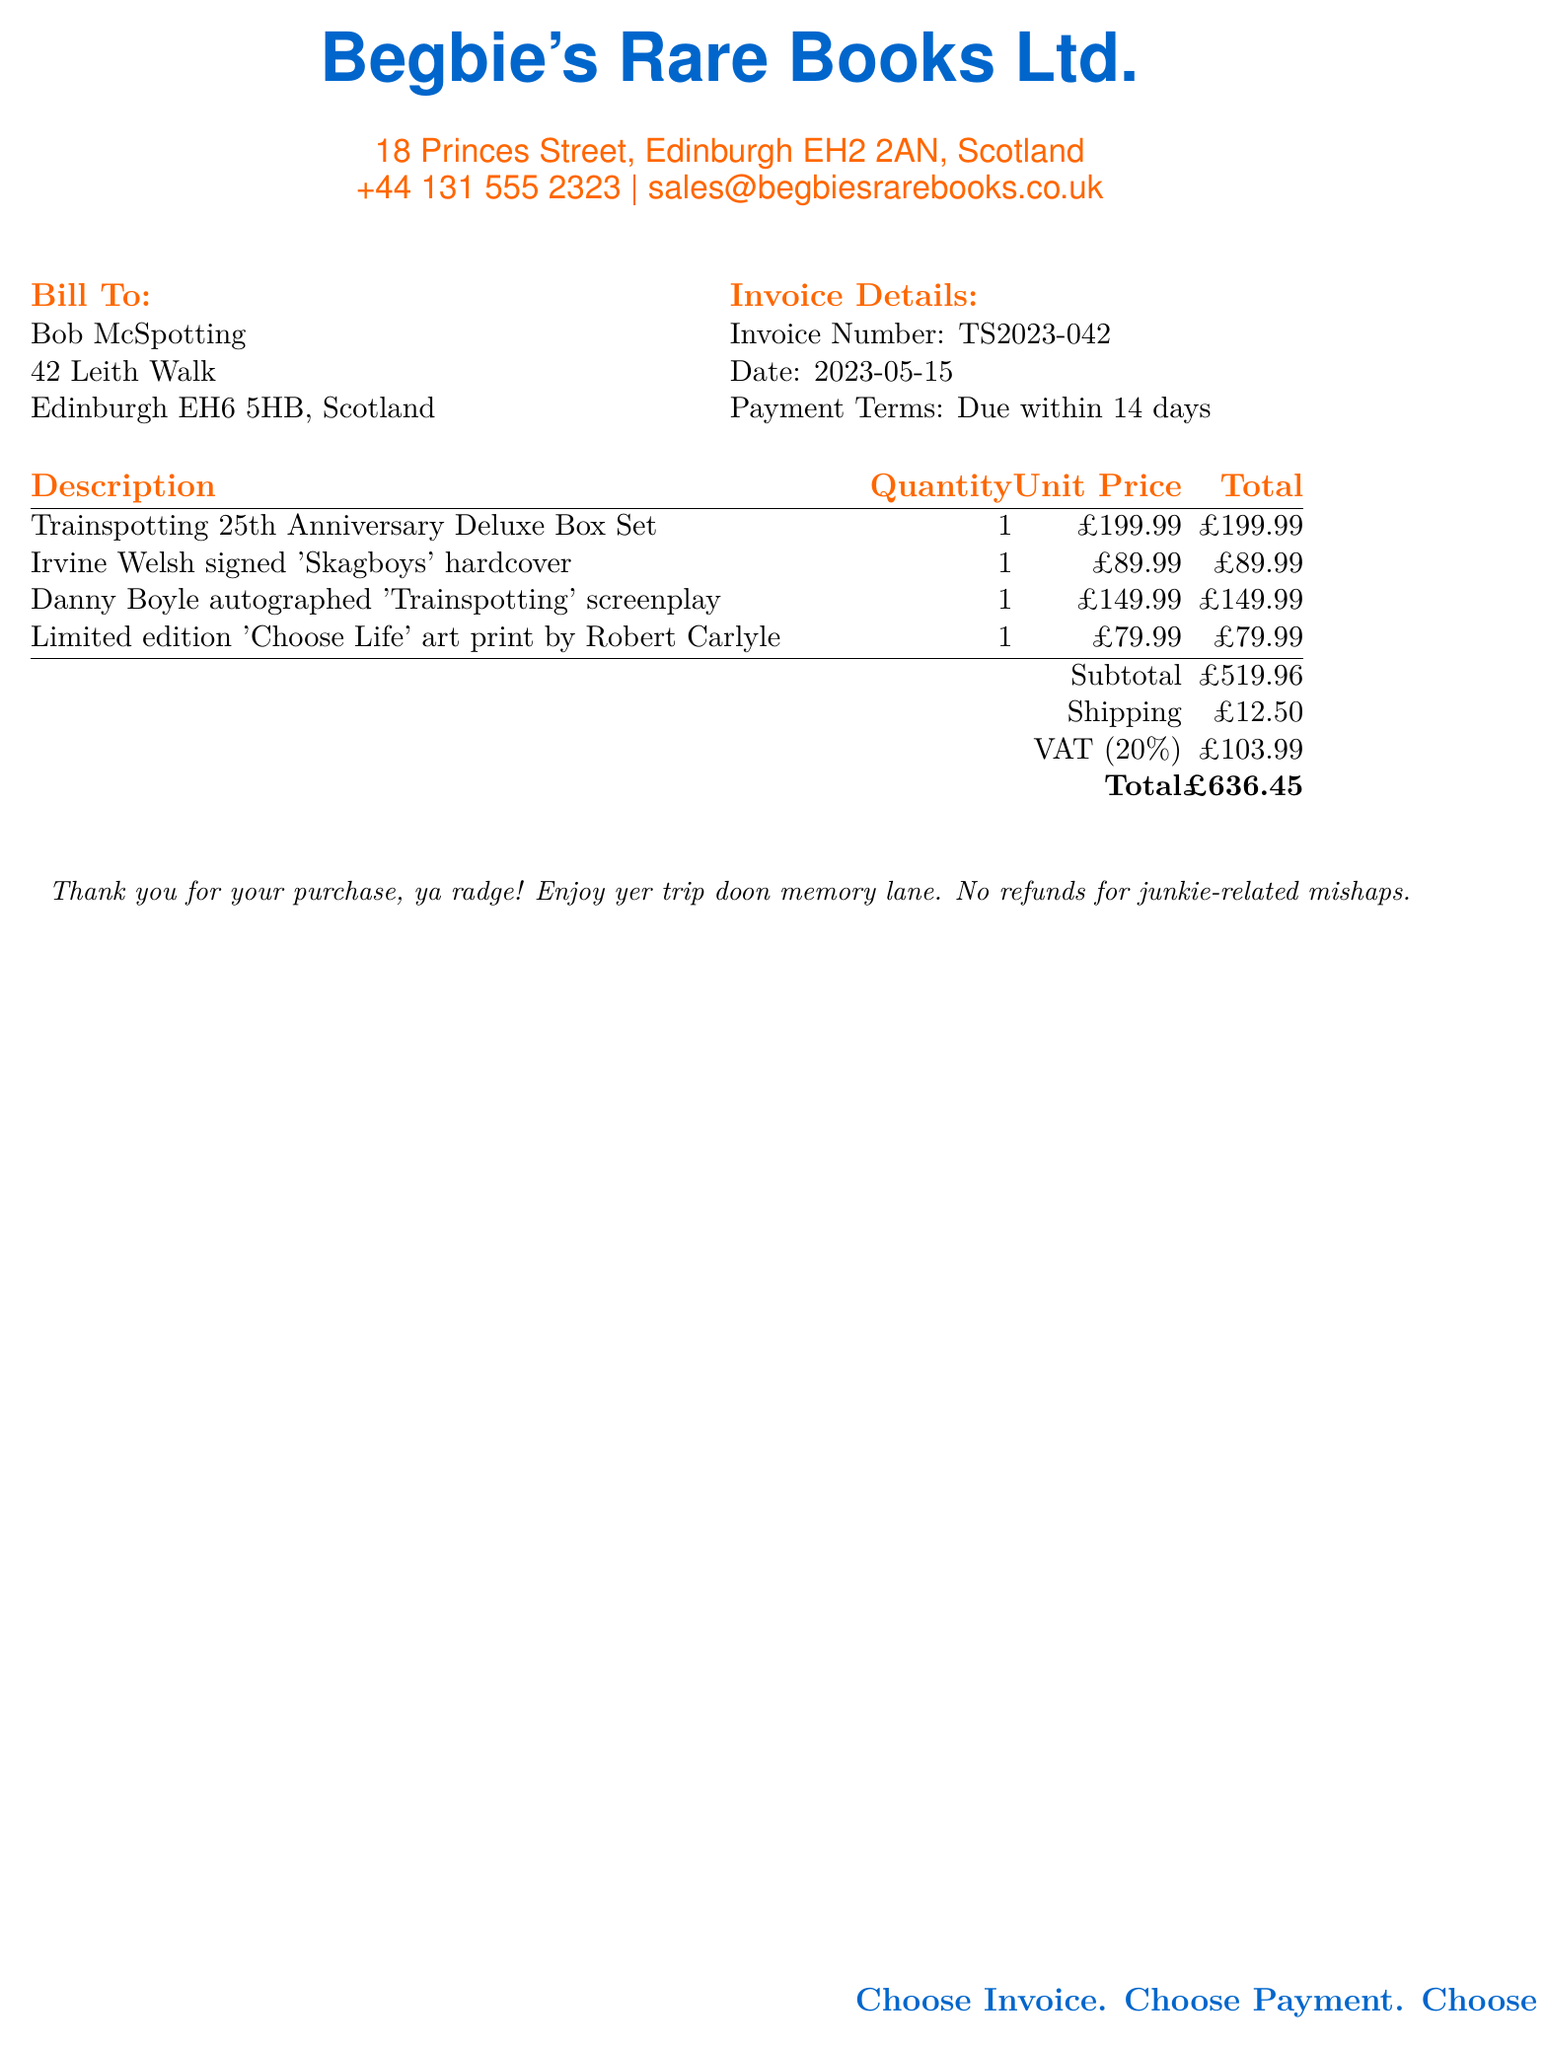What is the invoice number? The invoice number is specified in the document under invoice details, clearly labeled.
Answer: TS2023-042 What is the date of the invoice? The date is provided alongside the invoice number in the invoice details section of the document.
Answer: 2023-05-15 Who is the signed book by? The signed book is identified in the description part of the document, detailing the item and author.
Answer: Irvine Welsh What is the total amount due? The total amount due is clearly summarized at the end of the itemized list in the document, under the total line.
Answer: £636.45 What is the VAT percentage applied? The VAT percentage is mentioned in the document in relation to the tax calculations for the invoice total.
Answer: 20% How much is charged for shipping? The shipping cost is listed among the subtotal calculations in the document.
Answer: £12.50 What is included in the deluxe box set? The deluxe box set is a specific item listed in the description, representing a collectible item.
Answer: Trainspotting 25th Anniversary Deluxe Box Set How many items are in the order? The total count can be derived by summing the quantities of all items listed in the document.
Answer: 4 What is the address of the book seller? The seller's address is displayed prominently at the top of the document for contact details.
Answer: 18 Princes Street, Edinburgh EH2 2AN, Scotland 